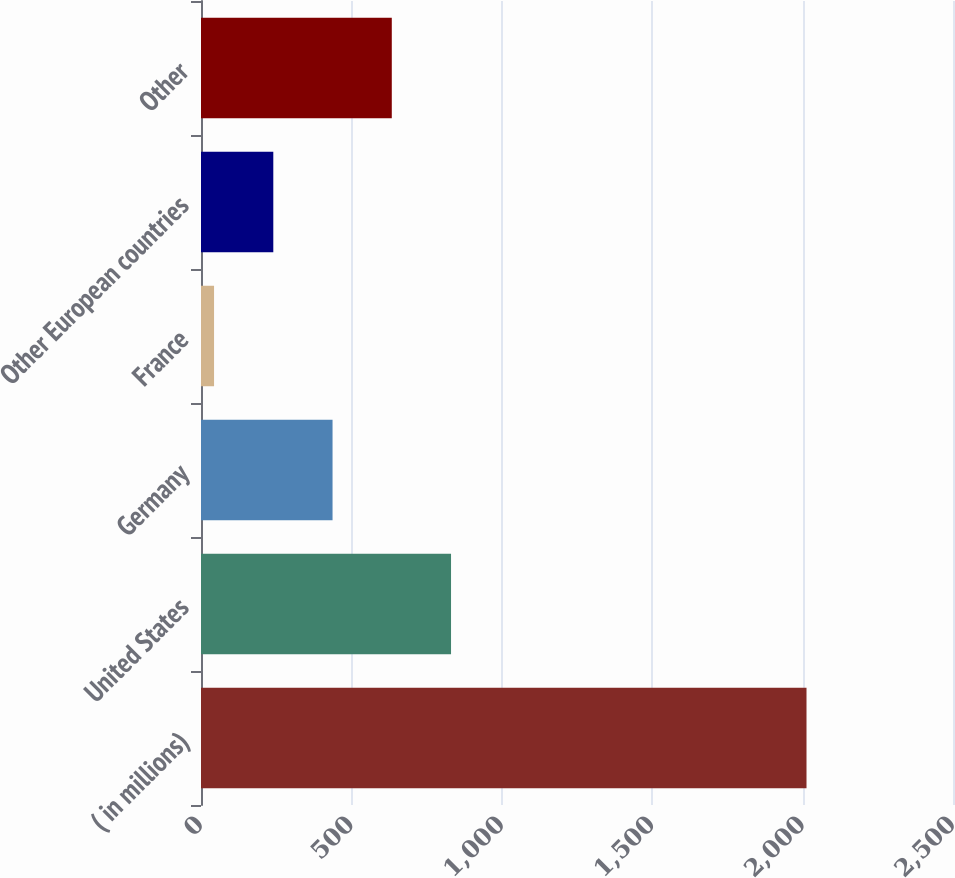Convert chart to OTSL. <chart><loc_0><loc_0><loc_500><loc_500><bar_chart><fcel>( in millions)<fcel>United States<fcel>Germany<fcel>France<fcel>Other European countries<fcel>Other<nl><fcel>2013<fcel>831.24<fcel>437.32<fcel>43.4<fcel>240.36<fcel>634.28<nl></chart> 